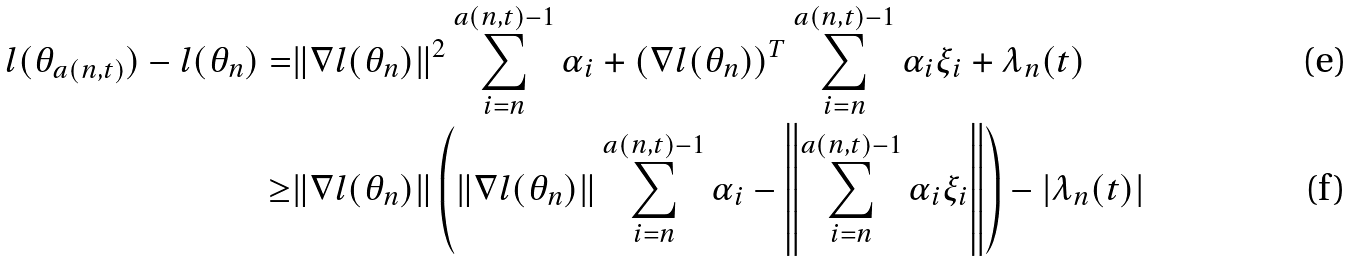Convert formula to latex. <formula><loc_0><loc_0><loc_500><loc_500>l ( \theta _ { a ( n , t ) } ) - l ( \theta _ { n } ) = & \| \nabla l ( \theta _ { n } ) \| ^ { 2 } \sum _ { i = n } ^ { a ( n , t ) - 1 } \alpha _ { i } + ( \nabla l ( \theta _ { n } ) ) ^ { T } \sum _ { i = n } ^ { a ( n , t ) - 1 } \alpha _ { i } \xi _ { i } + \lambda _ { n } ( t ) \\ \geq & \| \nabla l ( \theta _ { n } ) \| \left ( \| \nabla l ( \theta _ { n } ) \| \sum _ { i = n } ^ { a ( n , t ) - 1 } \alpha _ { i } - \left \| \sum _ { i = n } ^ { a ( n , t ) - 1 } \alpha _ { i } \xi _ { i } \right \| \right ) - | \lambda _ { n } ( t ) |</formula> 